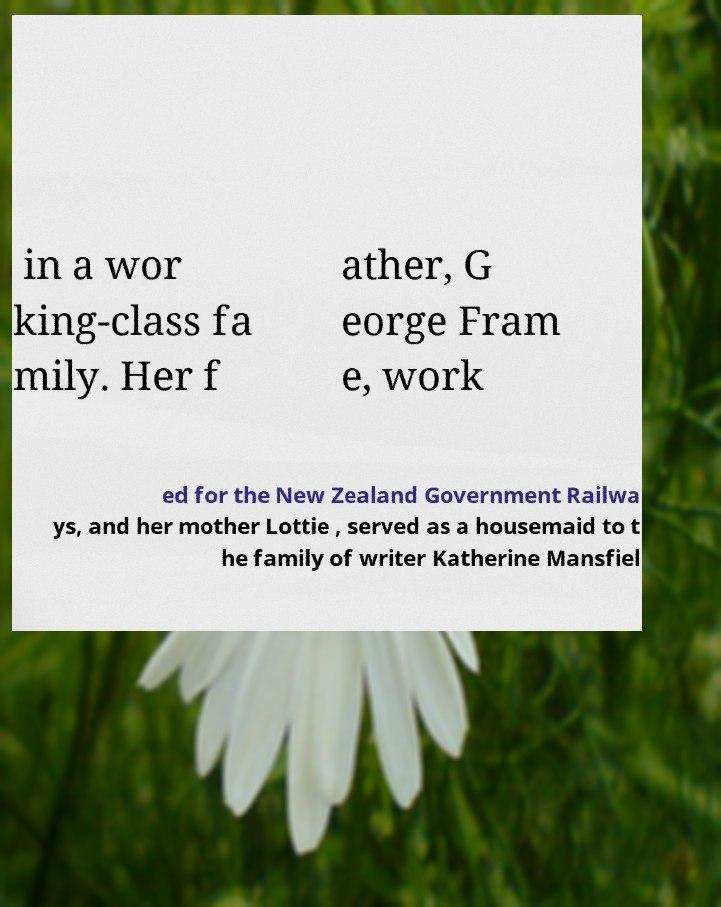Could you assist in decoding the text presented in this image and type it out clearly? in a wor king-class fa mily. Her f ather, G eorge Fram e, work ed for the New Zealand Government Railwa ys, and her mother Lottie , served as a housemaid to t he family of writer Katherine Mansfiel 